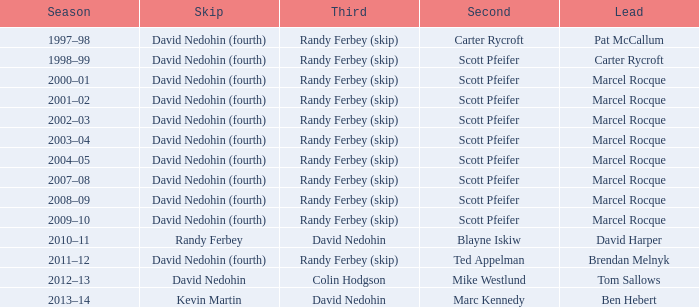Which Second has a Lead of ben hebert? Marc Kennedy. 